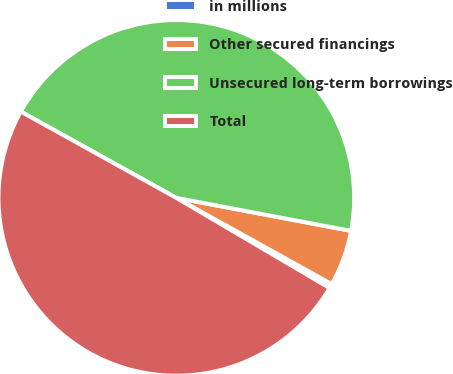<chart> <loc_0><loc_0><loc_500><loc_500><pie_chart><fcel>in millions<fcel>Other secured financings<fcel>Unsecured long-term borrowings<fcel>Total<nl><fcel>0.4%<fcel>5.09%<fcel>44.91%<fcel>49.6%<nl></chart> 